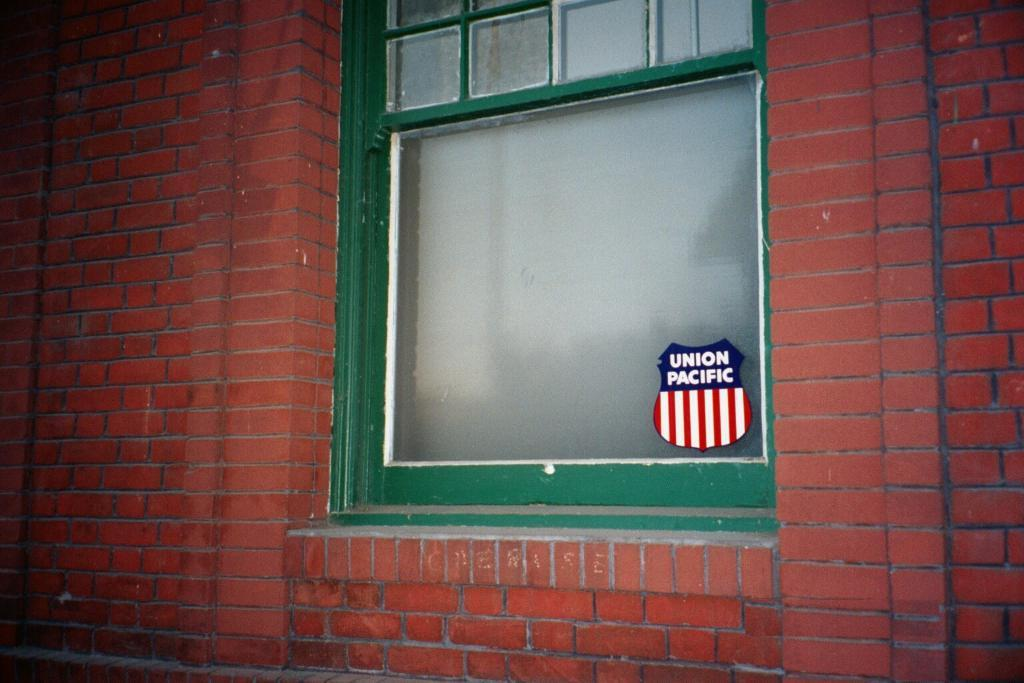<image>
Describe the image concisely. A green window frame sits in a red brick wall with a union pacific sticker stuck on its glass. 